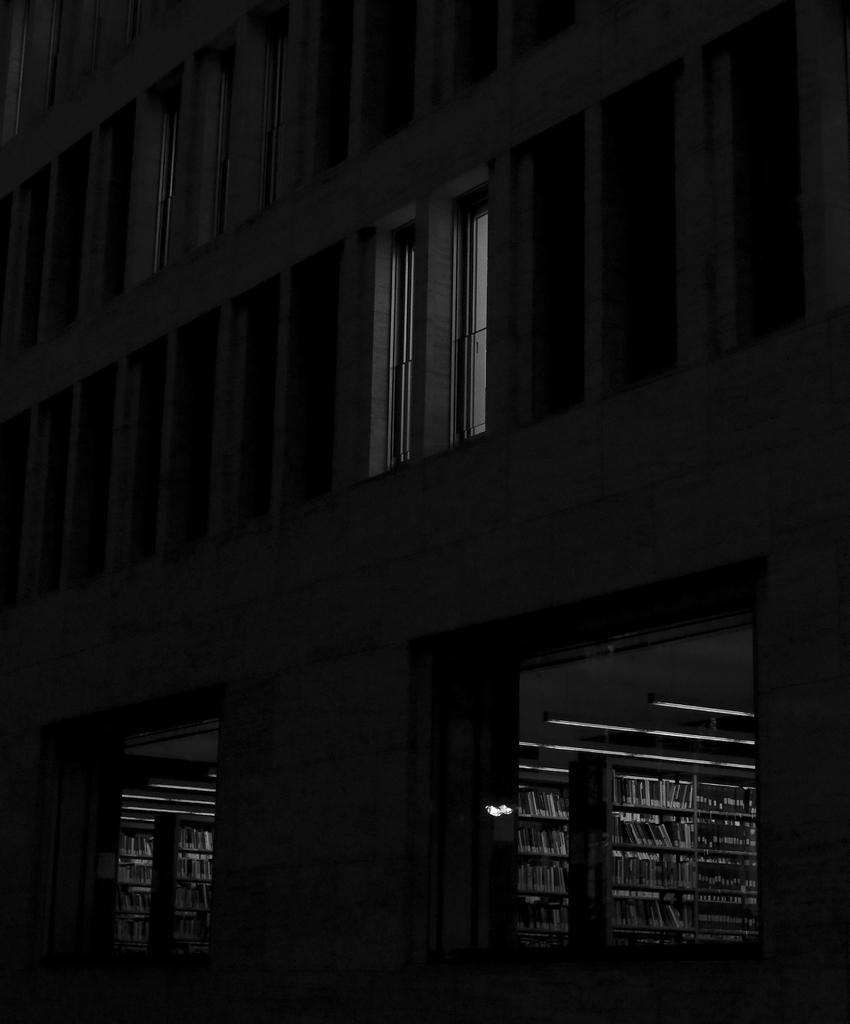What type of structure is visible in the image? There is a building in the image. What can be found inside the building? There are books in racks in the image. What type of trail can be seen leading to the building in the image? There is no trail visible in the image; it only shows a building with books in racks. 